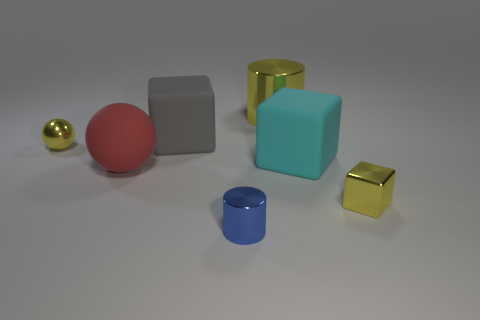Do the large shiny thing and the small shiny sphere have the same color?
Offer a very short reply. Yes. What material is the big cylinder?
Provide a short and direct response. Metal. What is the shape of the large red thing that is the same material as the cyan object?
Provide a short and direct response. Sphere. What number of other objects are the same shape as the cyan thing?
Give a very brief answer. 2. There is a blue cylinder; what number of big balls are behind it?
Keep it short and to the point. 1. There is a metallic cylinder that is to the right of the blue metallic object; does it have the same size as the matte cube that is behind the large cyan block?
Your answer should be compact. Yes. What number of other objects are there of the same size as the yellow ball?
Provide a short and direct response. 2. What is the material of the big thing that is to the right of the cylinder behind the small yellow thing behind the cyan block?
Provide a succinct answer. Rubber. There is a red object; does it have the same size as the shiny thing that is on the right side of the large yellow metal cylinder?
Offer a terse response. No. What is the size of the metal object that is to the right of the tiny blue metal cylinder and left of the yellow block?
Give a very brief answer. Large. 